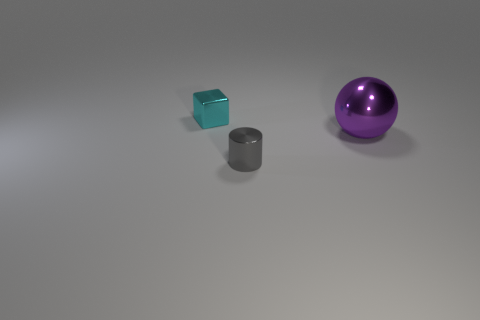Add 3 big purple rubber cylinders. How many objects exist? 6 Subtract all balls. How many objects are left? 2 Add 1 red cubes. How many red cubes exist? 1 Subtract 0 yellow cylinders. How many objects are left? 3 Subtract all large metallic balls. Subtract all purple things. How many objects are left? 1 Add 1 tiny cyan blocks. How many tiny cyan blocks are left? 2 